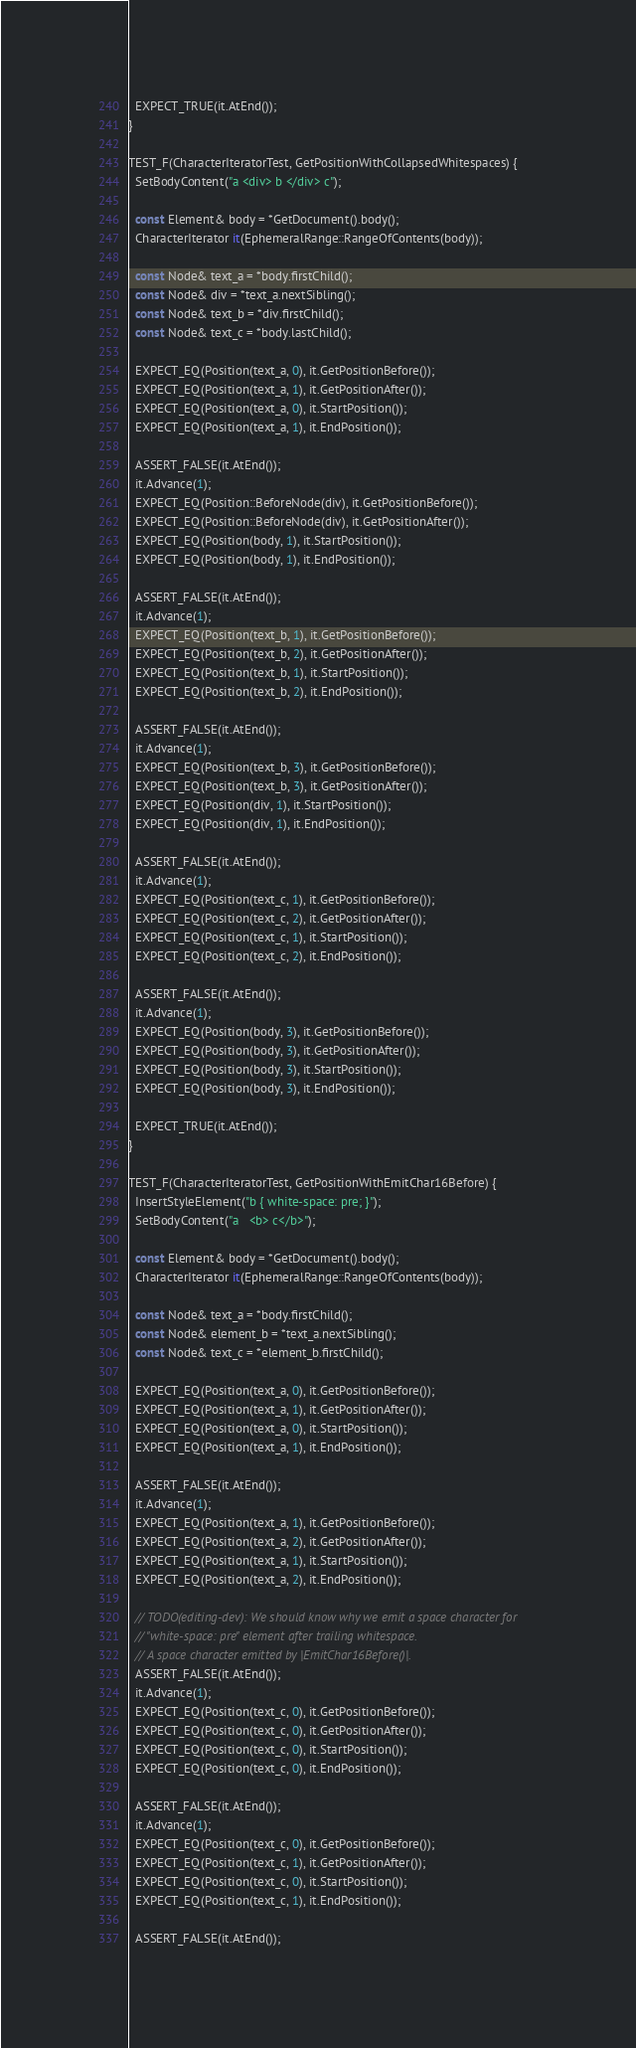Convert code to text. <code><loc_0><loc_0><loc_500><loc_500><_C++_>  EXPECT_TRUE(it.AtEnd());
}

TEST_F(CharacterIteratorTest, GetPositionWithCollapsedWhitespaces) {
  SetBodyContent("a <div> b </div> c");

  const Element& body = *GetDocument().body();
  CharacterIterator it(EphemeralRange::RangeOfContents(body));

  const Node& text_a = *body.firstChild();
  const Node& div = *text_a.nextSibling();
  const Node& text_b = *div.firstChild();
  const Node& text_c = *body.lastChild();

  EXPECT_EQ(Position(text_a, 0), it.GetPositionBefore());
  EXPECT_EQ(Position(text_a, 1), it.GetPositionAfter());
  EXPECT_EQ(Position(text_a, 0), it.StartPosition());
  EXPECT_EQ(Position(text_a, 1), it.EndPosition());

  ASSERT_FALSE(it.AtEnd());
  it.Advance(1);
  EXPECT_EQ(Position::BeforeNode(div), it.GetPositionBefore());
  EXPECT_EQ(Position::BeforeNode(div), it.GetPositionAfter());
  EXPECT_EQ(Position(body, 1), it.StartPosition());
  EXPECT_EQ(Position(body, 1), it.EndPosition());

  ASSERT_FALSE(it.AtEnd());
  it.Advance(1);
  EXPECT_EQ(Position(text_b, 1), it.GetPositionBefore());
  EXPECT_EQ(Position(text_b, 2), it.GetPositionAfter());
  EXPECT_EQ(Position(text_b, 1), it.StartPosition());
  EXPECT_EQ(Position(text_b, 2), it.EndPosition());

  ASSERT_FALSE(it.AtEnd());
  it.Advance(1);
  EXPECT_EQ(Position(text_b, 3), it.GetPositionBefore());
  EXPECT_EQ(Position(text_b, 3), it.GetPositionAfter());
  EXPECT_EQ(Position(div, 1), it.StartPosition());
  EXPECT_EQ(Position(div, 1), it.EndPosition());

  ASSERT_FALSE(it.AtEnd());
  it.Advance(1);
  EXPECT_EQ(Position(text_c, 1), it.GetPositionBefore());
  EXPECT_EQ(Position(text_c, 2), it.GetPositionAfter());
  EXPECT_EQ(Position(text_c, 1), it.StartPosition());
  EXPECT_EQ(Position(text_c, 2), it.EndPosition());

  ASSERT_FALSE(it.AtEnd());
  it.Advance(1);
  EXPECT_EQ(Position(body, 3), it.GetPositionBefore());
  EXPECT_EQ(Position(body, 3), it.GetPositionAfter());
  EXPECT_EQ(Position(body, 3), it.StartPosition());
  EXPECT_EQ(Position(body, 3), it.EndPosition());

  EXPECT_TRUE(it.AtEnd());
}

TEST_F(CharacterIteratorTest, GetPositionWithEmitChar16Before) {
  InsertStyleElement("b { white-space: pre; }");
  SetBodyContent("a   <b> c</b>");

  const Element& body = *GetDocument().body();
  CharacterIterator it(EphemeralRange::RangeOfContents(body));

  const Node& text_a = *body.firstChild();
  const Node& element_b = *text_a.nextSibling();
  const Node& text_c = *element_b.firstChild();

  EXPECT_EQ(Position(text_a, 0), it.GetPositionBefore());
  EXPECT_EQ(Position(text_a, 1), it.GetPositionAfter());
  EXPECT_EQ(Position(text_a, 0), it.StartPosition());
  EXPECT_EQ(Position(text_a, 1), it.EndPosition());

  ASSERT_FALSE(it.AtEnd());
  it.Advance(1);
  EXPECT_EQ(Position(text_a, 1), it.GetPositionBefore());
  EXPECT_EQ(Position(text_a, 2), it.GetPositionAfter());
  EXPECT_EQ(Position(text_a, 1), it.StartPosition());
  EXPECT_EQ(Position(text_a, 2), it.EndPosition());

  // TODO(editing-dev): We should know why we emit a space character for
  // "white-space: pre" element after trailing whitespace.
  // A space character emitted by |EmitChar16Before()|.
  ASSERT_FALSE(it.AtEnd());
  it.Advance(1);
  EXPECT_EQ(Position(text_c, 0), it.GetPositionBefore());
  EXPECT_EQ(Position(text_c, 0), it.GetPositionAfter());
  EXPECT_EQ(Position(text_c, 0), it.StartPosition());
  EXPECT_EQ(Position(text_c, 0), it.EndPosition());

  ASSERT_FALSE(it.AtEnd());
  it.Advance(1);
  EXPECT_EQ(Position(text_c, 0), it.GetPositionBefore());
  EXPECT_EQ(Position(text_c, 1), it.GetPositionAfter());
  EXPECT_EQ(Position(text_c, 0), it.StartPosition());
  EXPECT_EQ(Position(text_c, 1), it.EndPosition());

  ASSERT_FALSE(it.AtEnd());</code> 